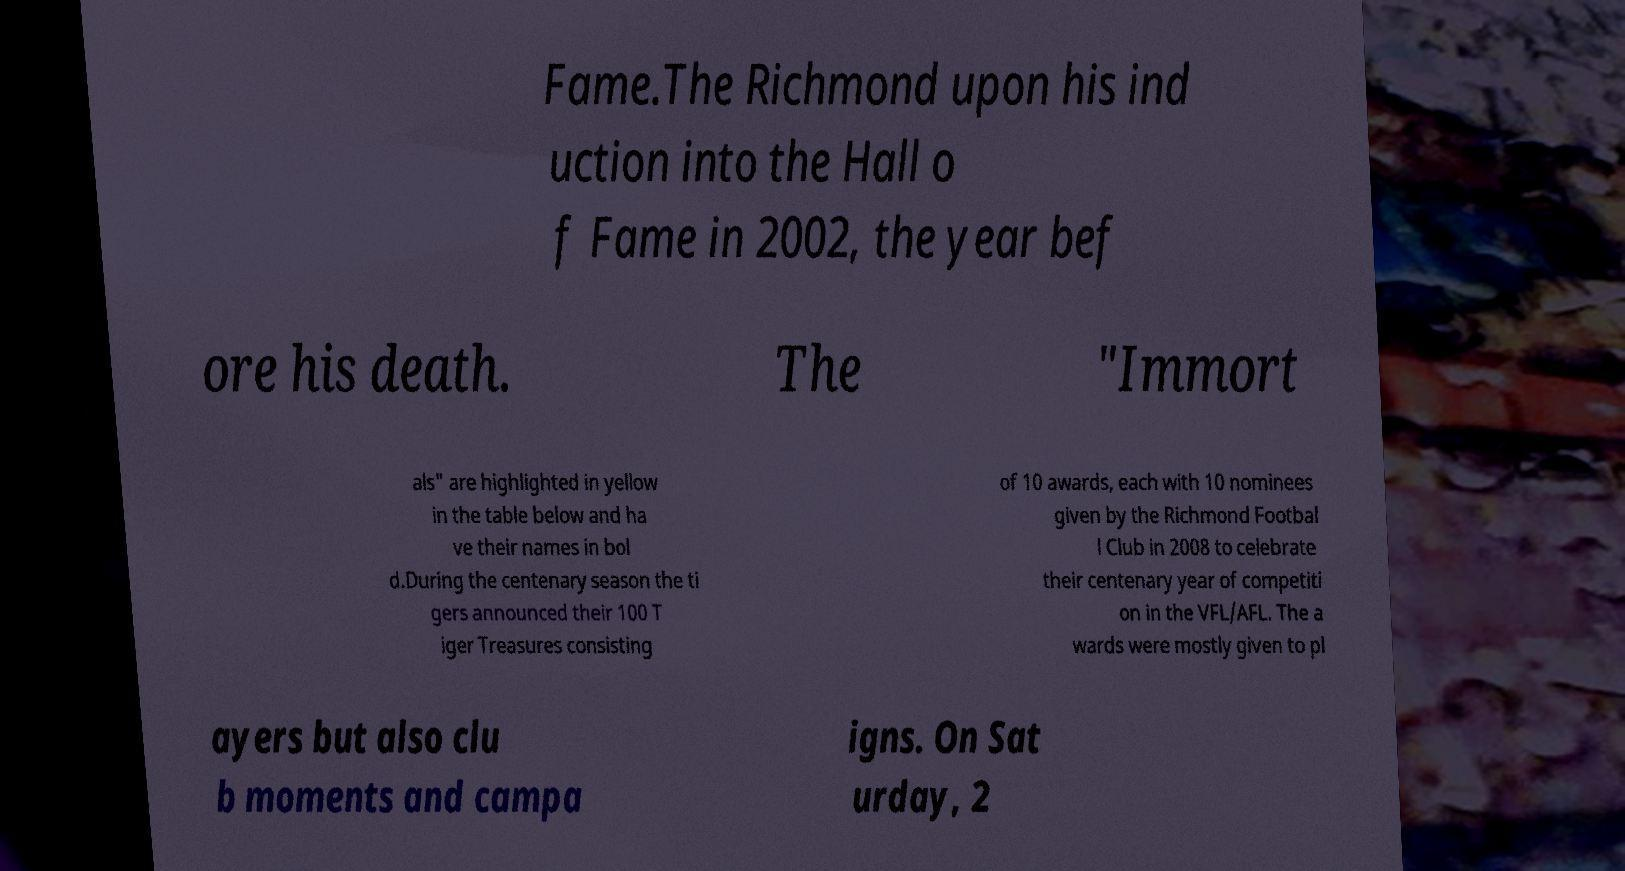I need the written content from this picture converted into text. Can you do that? Fame.The Richmond upon his ind uction into the Hall o f Fame in 2002, the year bef ore his death. The "Immort als" are highlighted in yellow in the table below and ha ve their names in bol d.During the centenary season the ti gers announced their 100 T iger Treasures consisting of 10 awards, each with 10 nominees given by the Richmond Footbal l Club in 2008 to celebrate their centenary year of competiti on in the VFL/AFL. The a wards were mostly given to pl ayers but also clu b moments and campa igns. On Sat urday, 2 